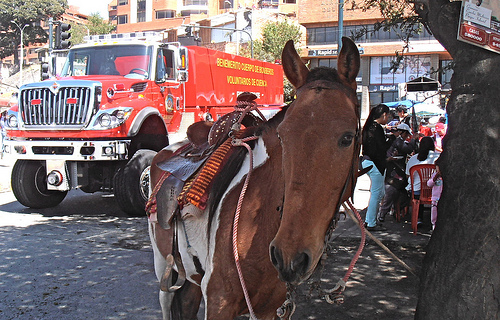<image>
Can you confirm if the truck is behind the horse? Yes. From this viewpoint, the truck is positioned behind the horse, with the horse partially or fully occluding the truck. 